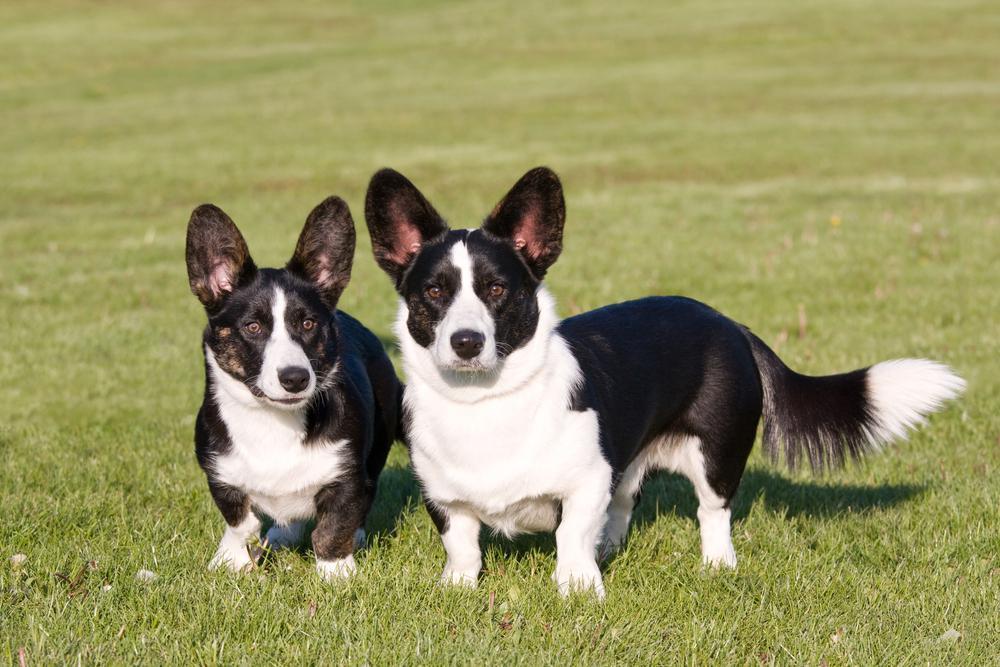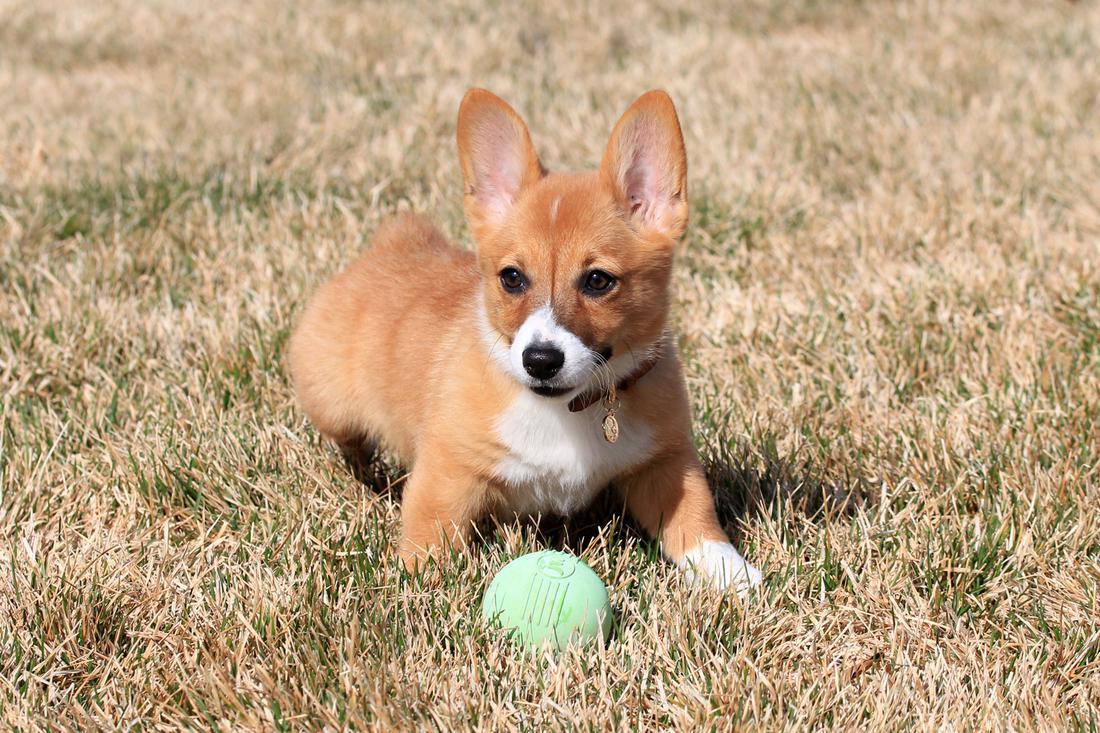The first image is the image on the left, the second image is the image on the right. Analyze the images presented: Is the assertion "An image contains exactly two corgi dogs standing on grass." valid? Answer yes or no. Yes. The first image is the image on the left, the second image is the image on the right. Examine the images to the left and right. Is the description "An image shows a pair of short-legged dogs standing facing forward and posed side-by-side." accurate? Answer yes or no. Yes. 